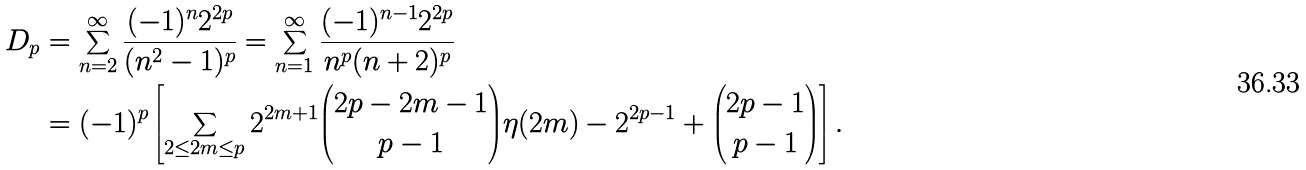<formula> <loc_0><loc_0><loc_500><loc_500>D _ { p } & = \sum _ { n = 2 } ^ { \infty } \frac { ( - 1 ) ^ { n } 2 ^ { 2 p } } { ( n ^ { 2 } - 1 ) ^ { p } } = \sum _ { n = 1 } ^ { \infty } \frac { ( - 1 ) ^ { n - 1 } 2 ^ { 2 p } } { n ^ { p } ( n + 2 ) ^ { p } } \\ & = ( - 1 ) ^ { p } \left [ \sum _ { 2 \leq 2 m \leq p } 2 ^ { 2 m + 1 } \binom { 2 p - 2 m - 1 } { p - 1 } \eta ( 2 m ) - 2 ^ { 2 p - 1 } + \binom { 2 p - 1 } { p - 1 } \right ] .</formula> 